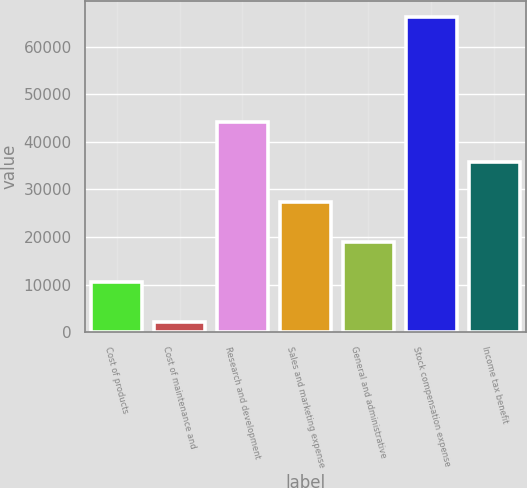<chart> <loc_0><loc_0><loc_500><loc_500><bar_chart><fcel>Cost of products<fcel>Cost of maintenance and<fcel>Research and development<fcel>Sales and marketing expense<fcel>General and administrative<fcel>Stock compensation expense<fcel>Income tax benefit<nl><fcel>10587.6<fcel>2164<fcel>44282<fcel>27434.8<fcel>19011.2<fcel>66329<fcel>35858.4<nl></chart> 